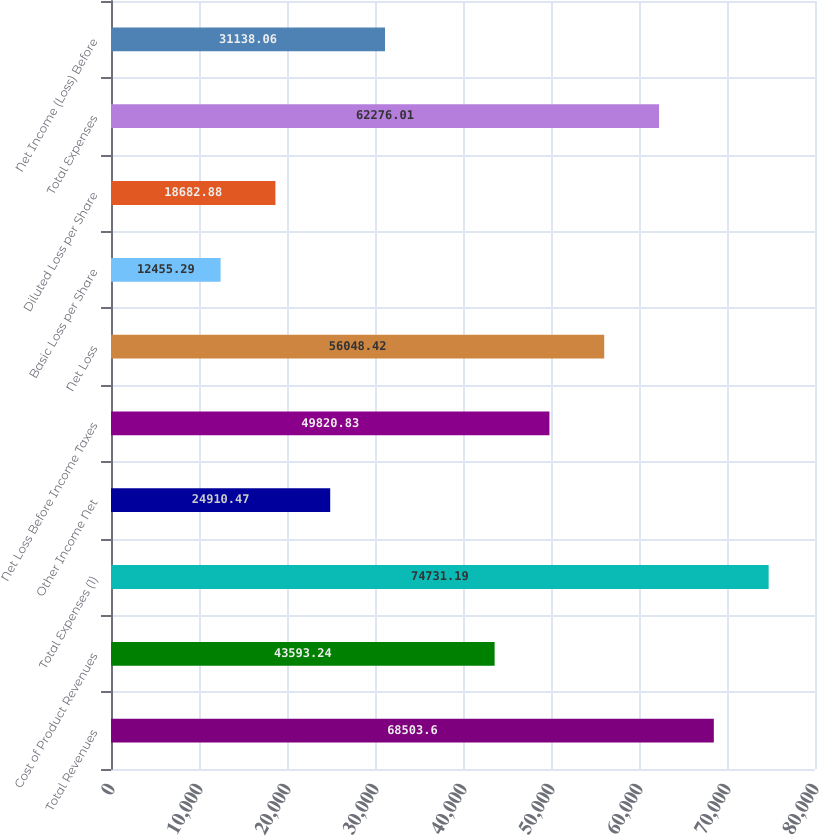Convert chart to OTSL. <chart><loc_0><loc_0><loc_500><loc_500><bar_chart><fcel>Total Revenues<fcel>Cost of Product Revenues<fcel>Total Expenses (1)<fcel>Other Income Net<fcel>Net Loss Before Income Taxes<fcel>Net Loss<fcel>Basic Loss per Share<fcel>Diluted Loss per Share<fcel>Total Expenses<fcel>Net Income (Loss) Before<nl><fcel>68503.6<fcel>43593.2<fcel>74731.2<fcel>24910.5<fcel>49820.8<fcel>56048.4<fcel>12455.3<fcel>18682.9<fcel>62276<fcel>31138.1<nl></chart> 